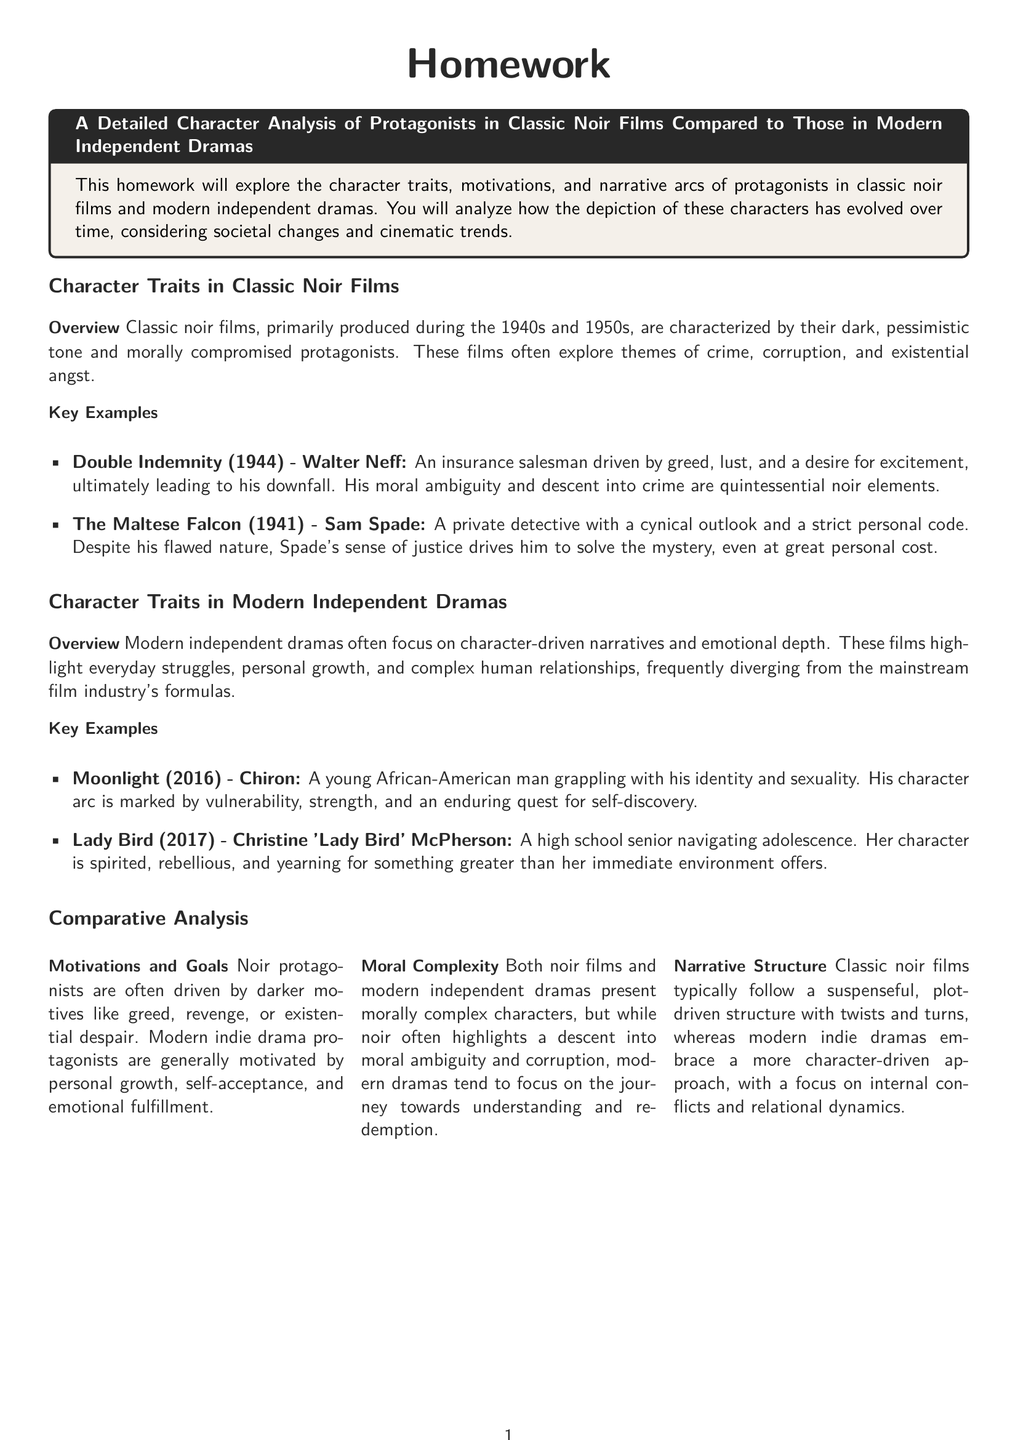What year was "Double Indemnity" released? "Double Indemnity" is mentioned in the context of classic noir films and is noted for its release year of 1944.
Answer: 1944 Who is the protagonist in "The Maltese Falcon"? The document lists "Sam Spade" as the protagonist in "The Maltese Falcon," a key example of classic noir films.
Answer: Sam Spade What is the main theme explored in modern independent dramas? The document mentions that modern independent dramas often highlight "personal growth" among other themes.
Answer: Personal growth Name one character from "Moonlight." "Chiron" is the protagonist of "Moonlight," which is provided as an example of modern independent dramas.
Answer: Chiron In which decade were classic noir films primarily produced? The overview section indicates that classic noir films were mainly produced during the 1940s and 1950s.
Answer: 1940s and 1950s What drives modern indie drama protagonists according to the document? The document explains that modern indie drama protagonists are usually motivated by "self-acceptance."
Answer: Self-acceptance What does the comparative analysis highlight about noir protagonists' motivations? The comparative analysis explains that noir protagonists are often driven by "darker motives."
Answer: Darker motives What type of narrative structure do classic noir films follow? The document states that classic noir films typically have a "plot-driven structure."
Answer: Plot-driven structure What is the purpose of this homework assignment? The homework assignment aims to explore character traits, motivations, and narrative arcs of the protagonists in noir films compared to modern independent dramas.
Answer: Explore character traits, motivations, and narrative arcs 